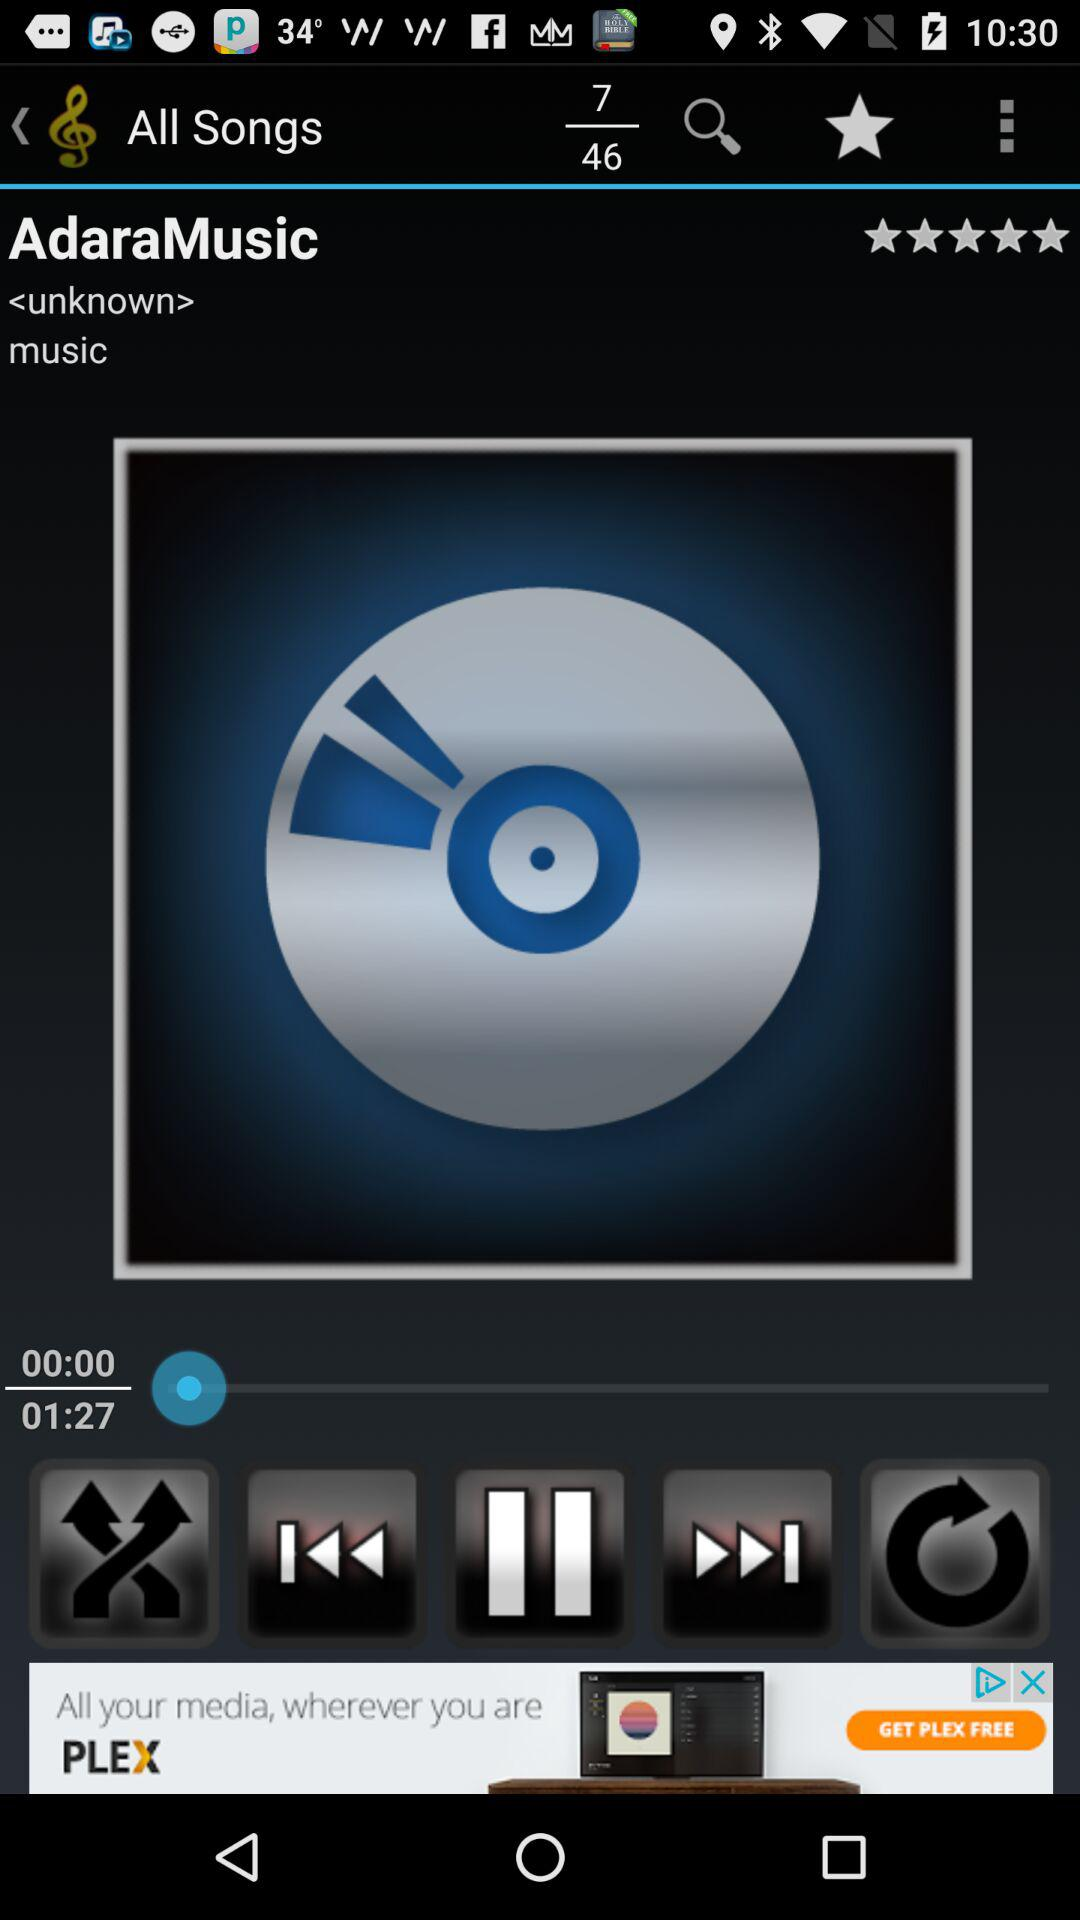What is the total duration of the "AdaraMusic"? The total duration of the "AdaraMusic" is 1 minute 27 seconds. 